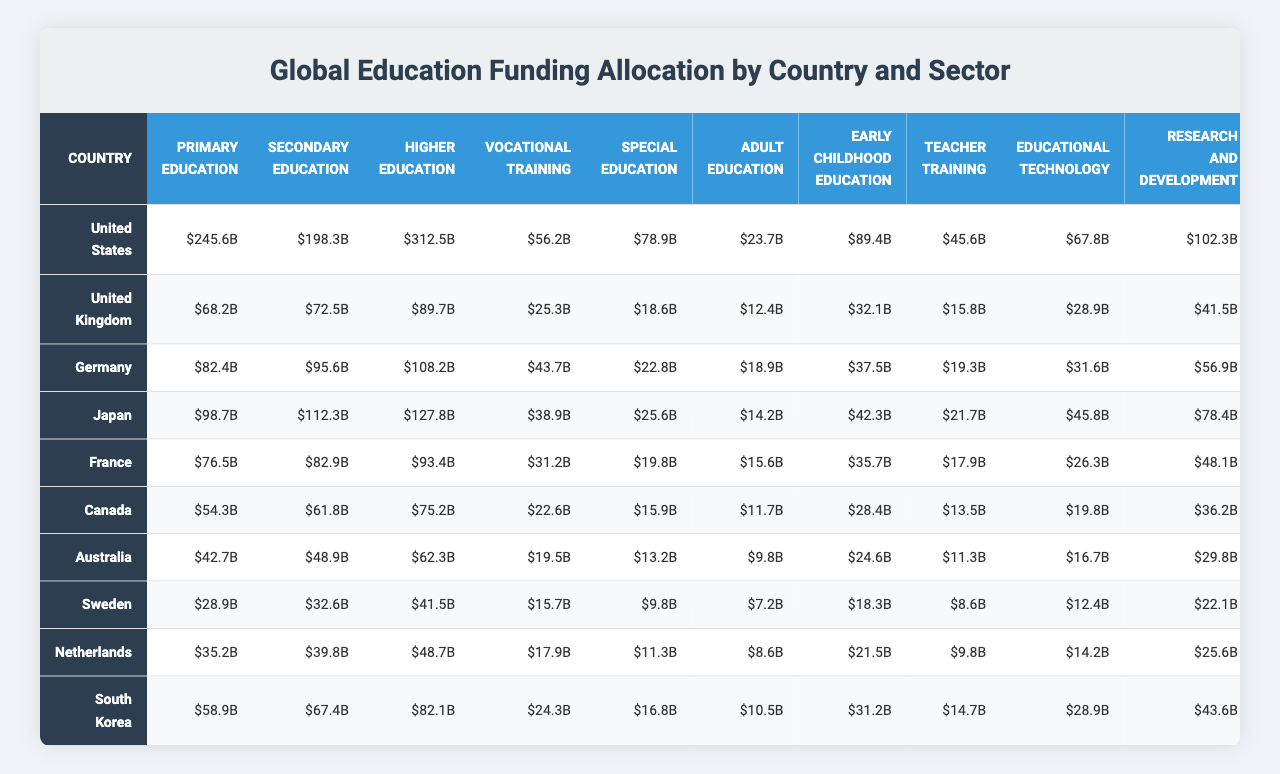What is the total funding allocated to Higher Education in Japan? Japan allocates funding of 127.8 billion dollars to Higher Education as shown in the corresponding cell.
Answer: 127.8 billion dollars Which country has the highest funding for Primary Education? By comparing the funding figures in the Primary Education column, the United States shows the highest allocation at 245.6 billion dollars.
Answer: United States What is the average funding for Special Education across all listed countries? To find the average, sum the Special Education funding for all countries: (78.9 + 18.6 + 22.8 + 25.6 + 19.8 + 15.9 + 13.2 + 9.8 + 11.3 + 16.8) = 292.7 billion dollars. There are 10 countries, so the average is 292.7 / 10 = 29.27 billion dollars.
Answer: 29.27 billion dollars Is the funding for Vocational Training in Germany greater than that in Canada? Germany has allocated 43.7 billion dollars for Vocational Training, while Canada has allocated 22.6 billion dollars, making it true that Germany's funding is greater.
Answer: Yes What is the total funding allocated to Educational Technology in the Netherlands and Sweden combined? The funding for Netherlands is 14.2 billion dollars and for Sweden is 12.4 billion dollars. Adding both gives 14.2 + 12.4 = 26.6 billion dollars.
Answer: 26.6 billion dollars Which country allocates the least funding to Adult Education? The funding for Adult Education in Australia is 9.8 billion dollars, which is less than all other countries' allocations in this category.
Answer: Australia What percentage of the total funding for Early Childhood Education is allocated by the United States? The US allocates 89.4 billion dollars to Early Childhood Education. The total for this category across all countries is 89.4 + 32.1 + 42.3 + 35.7 + 28.4 + 24.6 + 18.3 + 21.5 + 31.2 + 10.5 = 332.0 billion dollars. To find the percentage: (89.4 / 332.0) * 100 = 26.9%.
Answer: 26.9% How does the total funding for Secondary Education in South Korea compare to that of Japan? South Korea allocates 67.4 billion dollars while Japan allocates 112.3 billion dollars. Since 67.4 is less than 112.3, South Korea's funding is lower.
Answer: South Korea's funding is lower What is the difference in funding for Research and Development between the United States and Germany? The United States allocates 102.3 billion dollars and Germany allocates 56.9 billion dollars. The difference is 102.3 - 56.9 = 45.4 billion dollars.
Answer: 45.4 billion dollars Is the total funding for Primary Education combined across all countries greater than the funding for Adult Education? The total funding for Primary Education is 245.6 + 68.2 + 82.4 + 98.7 + 76.5 + 54.3 + 42.7 + 28.9 + 35.2 + 58.9 = 711.2 billion dollars. The total for Adult Education is 23.7 + 12.4 + 18.9 + 14.2 + 15.6 + 11.7 + 9.8 + 7.2 + 8.6 + 10.5 = 132.4 billion dollars. Since 711.2 is greater than 132.4, the statement is true.
Answer: Yes 